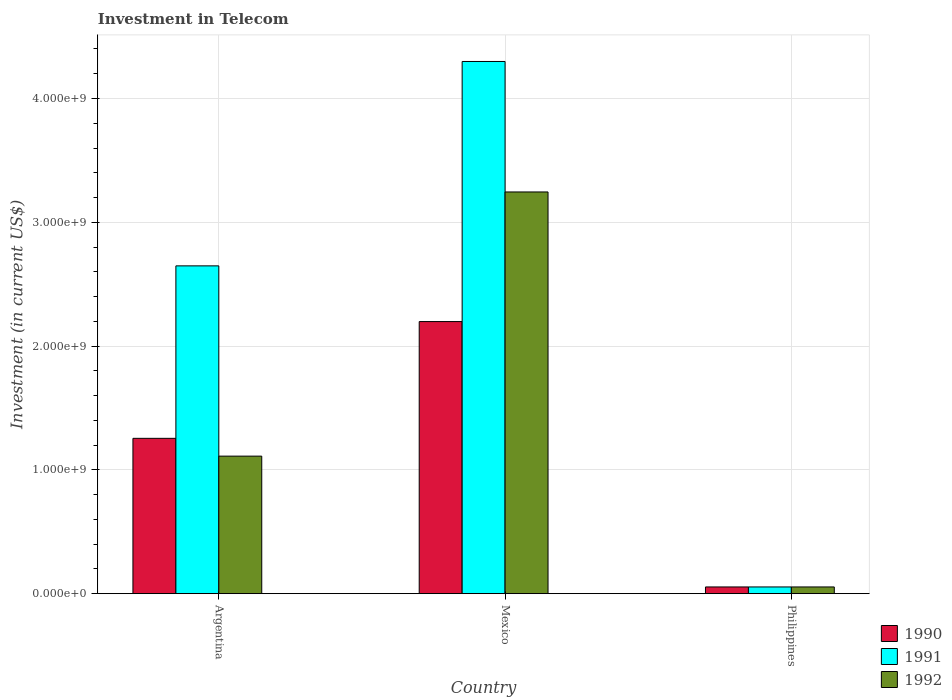How many groups of bars are there?
Offer a very short reply. 3. Are the number of bars per tick equal to the number of legend labels?
Your answer should be compact. Yes. Are the number of bars on each tick of the X-axis equal?
Keep it short and to the point. Yes. How many bars are there on the 3rd tick from the left?
Keep it short and to the point. 3. How many bars are there on the 3rd tick from the right?
Your answer should be very brief. 3. What is the label of the 1st group of bars from the left?
Provide a short and direct response. Argentina. What is the amount invested in telecom in 1990 in Mexico?
Your answer should be compact. 2.20e+09. Across all countries, what is the maximum amount invested in telecom in 1991?
Offer a terse response. 4.30e+09. Across all countries, what is the minimum amount invested in telecom in 1992?
Give a very brief answer. 5.42e+07. In which country was the amount invested in telecom in 1990 maximum?
Provide a succinct answer. Mexico. In which country was the amount invested in telecom in 1990 minimum?
Your answer should be compact. Philippines. What is the total amount invested in telecom in 1991 in the graph?
Offer a very short reply. 7.00e+09. What is the difference between the amount invested in telecom in 1992 in Mexico and that in Philippines?
Your answer should be very brief. 3.19e+09. What is the difference between the amount invested in telecom in 1991 in Philippines and the amount invested in telecom in 1992 in Argentina?
Keep it short and to the point. -1.06e+09. What is the average amount invested in telecom in 1991 per country?
Your response must be concise. 2.33e+09. What is the difference between the amount invested in telecom of/in 1992 and amount invested in telecom of/in 1990 in Philippines?
Keep it short and to the point. 0. What is the ratio of the amount invested in telecom in 1992 in Mexico to that in Philippines?
Provide a short and direct response. 59.87. Is the difference between the amount invested in telecom in 1992 in Mexico and Philippines greater than the difference between the amount invested in telecom in 1990 in Mexico and Philippines?
Ensure brevity in your answer.  Yes. What is the difference between the highest and the second highest amount invested in telecom in 1990?
Your answer should be very brief. 9.43e+08. What is the difference between the highest and the lowest amount invested in telecom in 1990?
Your response must be concise. 2.14e+09. Is the sum of the amount invested in telecom in 1990 in Argentina and Philippines greater than the maximum amount invested in telecom in 1992 across all countries?
Your answer should be very brief. No. What does the 3rd bar from the left in Philippines represents?
Ensure brevity in your answer.  1992. What does the 1st bar from the right in Philippines represents?
Ensure brevity in your answer.  1992. How many bars are there?
Provide a short and direct response. 9. Are the values on the major ticks of Y-axis written in scientific E-notation?
Your answer should be compact. Yes. How many legend labels are there?
Offer a very short reply. 3. What is the title of the graph?
Your response must be concise. Investment in Telecom. What is the label or title of the X-axis?
Provide a succinct answer. Country. What is the label or title of the Y-axis?
Provide a succinct answer. Investment (in current US$). What is the Investment (in current US$) in 1990 in Argentina?
Your response must be concise. 1.25e+09. What is the Investment (in current US$) of 1991 in Argentina?
Make the answer very short. 2.65e+09. What is the Investment (in current US$) of 1992 in Argentina?
Offer a very short reply. 1.11e+09. What is the Investment (in current US$) in 1990 in Mexico?
Ensure brevity in your answer.  2.20e+09. What is the Investment (in current US$) in 1991 in Mexico?
Make the answer very short. 4.30e+09. What is the Investment (in current US$) of 1992 in Mexico?
Provide a succinct answer. 3.24e+09. What is the Investment (in current US$) of 1990 in Philippines?
Give a very brief answer. 5.42e+07. What is the Investment (in current US$) of 1991 in Philippines?
Ensure brevity in your answer.  5.42e+07. What is the Investment (in current US$) of 1992 in Philippines?
Make the answer very short. 5.42e+07. Across all countries, what is the maximum Investment (in current US$) in 1990?
Provide a succinct answer. 2.20e+09. Across all countries, what is the maximum Investment (in current US$) of 1991?
Ensure brevity in your answer.  4.30e+09. Across all countries, what is the maximum Investment (in current US$) of 1992?
Make the answer very short. 3.24e+09. Across all countries, what is the minimum Investment (in current US$) of 1990?
Provide a succinct answer. 5.42e+07. Across all countries, what is the minimum Investment (in current US$) in 1991?
Provide a short and direct response. 5.42e+07. Across all countries, what is the minimum Investment (in current US$) of 1992?
Your answer should be compact. 5.42e+07. What is the total Investment (in current US$) of 1990 in the graph?
Your answer should be very brief. 3.51e+09. What is the total Investment (in current US$) of 1991 in the graph?
Give a very brief answer. 7.00e+09. What is the total Investment (in current US$) of 1992 in the graph?
Your answer should be very brief. 4.41e+09. What is the difference between the Investment (in current US$) in 1990 in Argentina and that in Mexico?
Provide a short and direct response. -9.43e+08. What is the difference between the Investment (in current US$) in 1991 in Argentina and that in Mexico?
Offer a very short reply. -1.65e+09. What is the difference between the Investment (in current US$) in 1992 in Argentina and that in Mexico?
Provide a succinct answer. -2.13e+09. What is the difference between the Investment (in current US$) in 1990 in Argentina and that in Philippines?
Ensure brevity in your answer.  1.20e+09. What is the difference between the Investment (in current US$) of 1991 in Argentina and that in Philippines?
Offer a very short reply. 2.59e+09. What is the difference between the Investment (in current US$) of 1992 in Argentina and that in Philippines?
Keep it short and to the point. 1.06e+09. What is the difference between the Investment (in current US$) in 1990 in Mexico and that in Philippines?
Offer a very short reply. 2.14e+09. What is the difference between the Investment (in current US$) of 1991 in Mexico and that in Philippines?
Your response must be concise. 4.24e+09. What is the difference between the Investment (in current US$) of 1992 in Mexico and that in Philippines?
Make the answer very short. 3.19e+09. What is the difference between the Investment (in current US$) in 1990 in Argentina and the Investment (in current US$) in 1991 in Mexico?
Your answer should be compact. -3.04e+09. What is the difference between the Investment (in current US$) in 1990 in Argentina and the Investment (in current US$) in 1992 in Mexico?
Offer a very short reply. -1.99e+09. What is the difference between the Investment (in current US$) of 1991 in Argentina and the Investment (in current US$) of 1992 in Mexico?
Your answer should be compact. -5.97e+08. What is the difference between the Investment (in current US$) of 1990 in Argentina and the Investment (in current US$) of 1991 in Philippines?
Give a very brief answer. 1.20e+09. What is the difference between the Investment (in current US$) in 1990 in Argentina and the Investment (in current US$) in 1992 in Philippines?
Give a very brief answer. 1.20e+09. What is the difference between the Investment (in current US$) in 1991 in Argentina and the Investment (in current US$) in 1992 in Philippines?
Make the answer very short. 2.59e+09. What is the difference between the Investment (in current US$) in 1990 in Mexico and the Investment (in current US$) in 1991 in Philippines?
Ensure brevity in your answer.  2.14e+09. What is the difference between the Investment (in current US$) in 1990 in Mexico and the Investment (in current US$) in 1992 in Philippines?
Your answer should be compact. 2.14e+09. What is the difference between the Investment (in current US$) in 1991 in Mexico and the Investment (in current US$) in 1992 in Philippines?
Your response must be concise. 4.24e+09. What is the average Investment (in current US$) in 1990 per country?
Keep it short and to the point. 1.17e+09. What is the average Investment (in current US$) of 1991 per country?
Offer a very short reply. 2.33e+09. What is the average Investment (in current US$) of 1992 per country?
Give a very brief answer. 1.47e+09. What is the difference between the Investment (in current US$) of 1990 and Investment (in current US$) of 1991 in Argentina?
Your response must be concise. -1.39e+09. What is the difference between the Investment (in current US$) of 1990 and Investment (in current US$) of 1992 in Argentina?
Offer a very short reply. 1.44e+08. What is the difference between the Investment (in current US$) in 1991 and Investment (in current US$) in 1992 in Argentina?
Your answer should be very brief. 1.54e+09. What is the difference between the Investment (in current US$) of 1990 and Investment (in current US$) of 1991 in Mexico?
Give a very brief answer. -2.10e+09. What is the difference between the Investment (in current US$) of 1990 and Investment (in current US$) of 1992 in Mexico?
Your answer should be very brief. -1.05e+09. What is the difference between the Investment (in current US$) in 1991 and Investment (in current US$) in 1992 in Mexico?
Make the answer very short. 1.05e+09. What is the difference between the Investment (in current US$) of 1990 and Investment (in current US$) of 1991 in Philippines?
Provide a succinct answer. 0. What is the difference between the Investment (in current US$) of 1990 and Investment (in current US$) of 1992 in Philippines?
Provide a short and direct response. 0. What is the ratio of the Investment (in current US$) in 1990 in Argentina to that in Mexico?
Ensure brevity in your answer.  0.57. What is the ratio of the Investment (in current US$) in 1991 in Argentina to that in Mexico?
Make the answer very short. 0.62. What is the ratio of the Investment (in current US$) of 1992 in Argentina to that in Mexico?
Your answer should be compact. 0.34. What is the ratio of the Investment (in current US$) of 1990 in Argentina to that in Philippines?
Offer a terse response. 23.15. What is the ratio of the Investment (in current US$) in 1991 in Argentina to that in Philippines?
Your answer should be compact. 48.86. What is the ratio of the Investment (in current US$) of 1992 in Argentina to that in Philippines?
Offer a terse response. 20.5. What is the ratio of the Investment (in current US$) of 1990 in Mexico to that in Philippines?
Make the answer very short. 40.55. What is the ratio of the Investment (in current US$) of 1991 in Mexico to that in Philippines?
Offer a terse response. 79.32. What is the ratio of the Investment (in current US$) of 1992 in Mexico to that in Philippines?
Provide a short and direct response. 59.87. What is the difference between the highest and the second highest Investment (in current US$) in 1990?
Your answer should be very brief. 9.43e+08. What is the difference between the highest and the second highest Investment (in current US$) of 1991?
Your answer should be compact. 1.65e+09. What is the difference between the highest and the second highest Investment (in current US$) of 1992?
Offer a very short reply. 2.13e+09. What is the difference between the highest and the lowest Investment (in current US$) of 1990?
Offer a very short reply. 2.14e+09. What is the difference between the highest and the lowest Investment (in current US$) in 1991?
Provide a succinct answer. 4.24e+09. What is the difference between the highest and the lowest Investment (in current US$) in 1992?
Offer a terse response. 3.19e+09. 